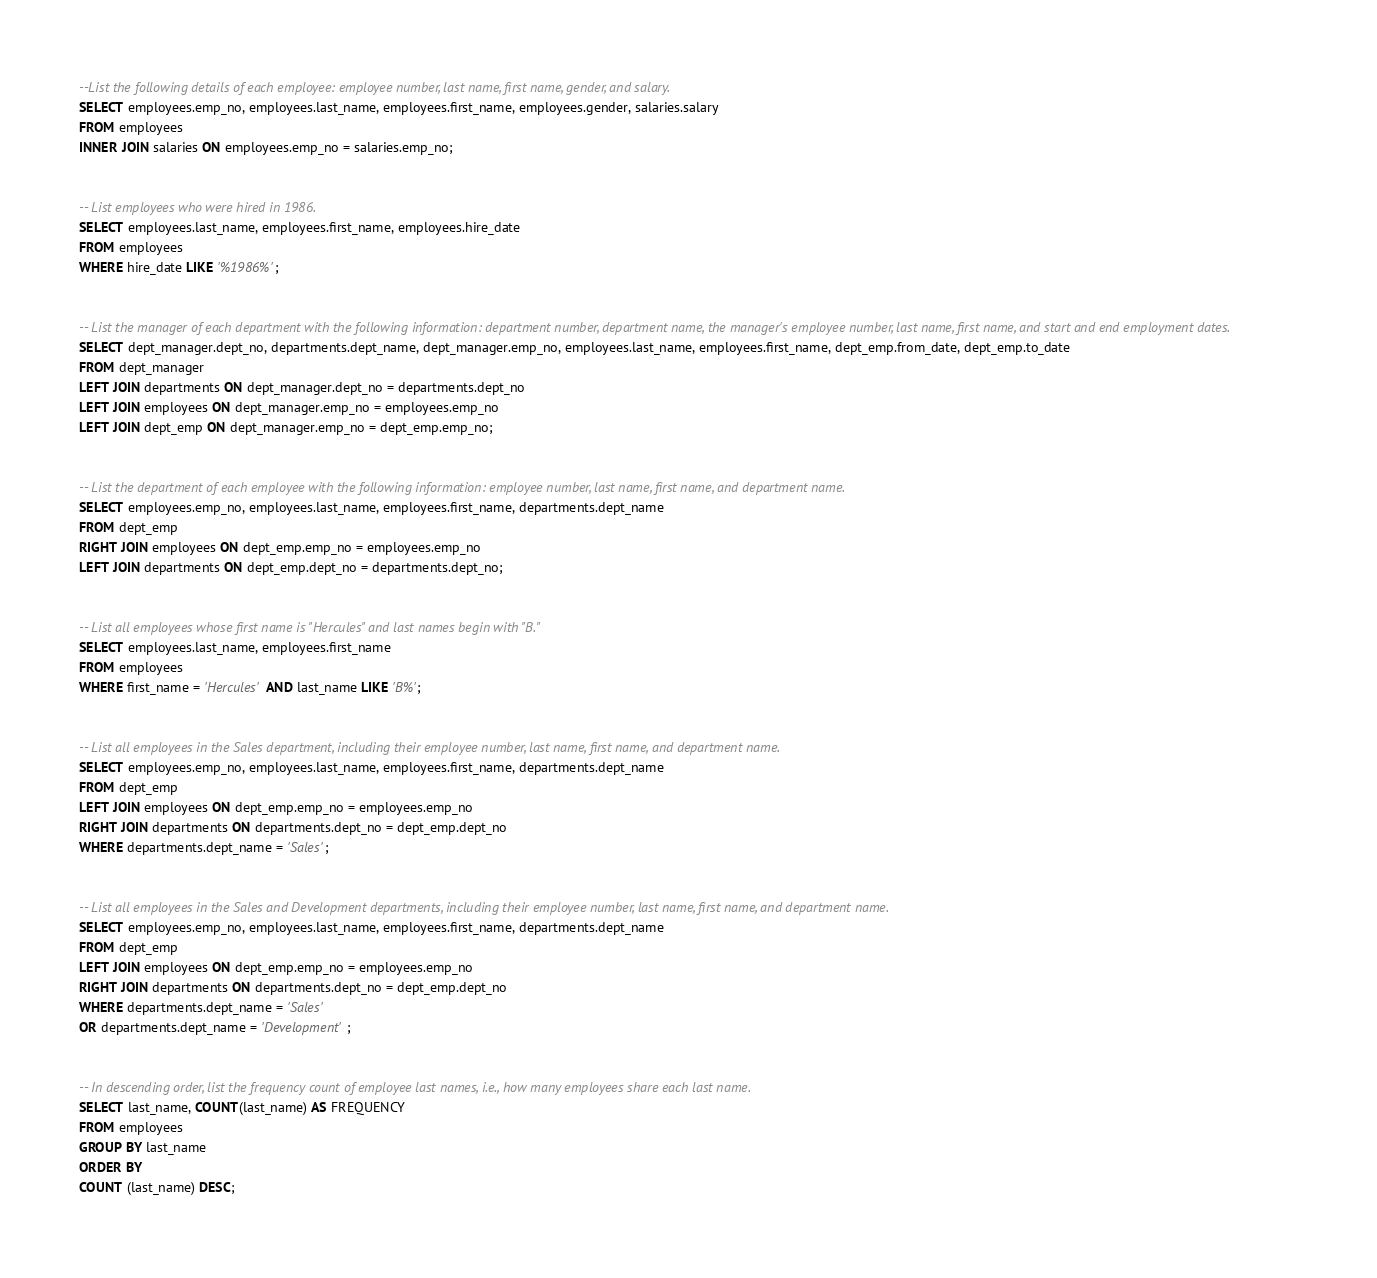<code> <loc_0><loc_0><loc_500><loc_500><_SQL_>--List the following details of each employee: employee number, last name, first name, gender, and salary.
SELECT employees.emp_no, employees.last_name, employees.first_name, employees.gender, salaries.salary 
FROM employees 
INNER JOIN salaries ON employees.emp_no = salaries.emp_no;


-- List employees who were hired in 1986.
SELECT employees.last_name, employees.first_name, employees.hire_date 
FROM employees
WHERE hire_date LIKE '%1986%';


-- List the manager of each department with the following information: department number, department name, the manager's employee number, last name, first name, and start and end employment dates.
SELECT dept_manager.dept_no, departments.dept_name, dept_manager.emp_no, employees.last_name, employees.first_name, dept_emp.from_date, dept_emp.to_date
FROM dept_manager
LEFT JOIN departments ON dept_manager.dept_no = departments.dept_no
LEFT JOIN employees ON dept_manager.emp_no = employees.emp_no
LEFT JOIN dept_emp ON dept_manager.emp_no = dept_emp.emp_no;


-- List the department of each employee with the following information: employee number, last name, first name, and department name.
SELECT employees.emp_no, employees.last_name, employees.first_name, departments.dept_name
FROM dept_emp
RIGHT JOIN employees ON dept_emp.emp_no = employees.emp_no
LEFT JOIN departments ON dept_emp.dept_no = departments.dept_no;


-- List all employees whose first name is "Hercules" and last names begin with "B."
SELECT employees.last_name, employees.first_name
FROM employees
WHERE first_name = 'Hercules' AND last_name LIKE 'B%';


-- List all employees in the Sales department, including their employee number, last name, first name, and department name.
SELECT employees.emp_no, employees.last_name, employees.first_name, departments.dept_name
FROM dept_emp 
LEFT JOIN employees ON dept_emp.emp_no = employees.emp_no
RIGHT JOIN departments ON departments.dept_no = dept_emp.dept_no
WHERE departments.dept_name = 'Sales';


-- List all employees in the Sales and Development departments, including their employee number, last name, first name, and department name.
SELECT employees.emp_no, employees.last_name, employees.first_name, departments.dept_name
FROM dept_emp 
LEFT JOIN employees ON dept_emp.emp_no = employees.emp_no
RIGHT JOIN departments ON departments.dept_no = dept_emp.dept_no
WHERE departments.dept_name = 'Sales' 
OR departments.dept_name = 'Development';


-- In descending order, list the frequency count of employee last names, i.e., how many employees share each last name.
SELECT last_name, COUNT(last_name) AS FREQUENCY
FROM employees
GROUP BY last_name
ORDER BY
COUNT (last_name) DESC;

</code> 